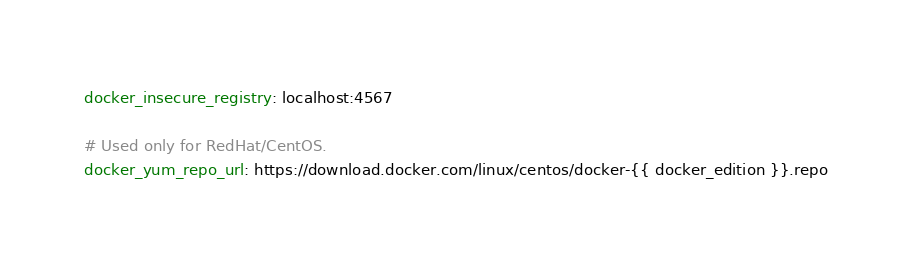Convert code to text. <code><loc_0><loc_0><loc_500><loc_500><_YAML_>docker_insecure_registry: localhost:4567

# Used only for RedHat/CentOS.
docker_yum_repo_url: https://download.docker.com/linux/centos/docker-{{ docker_edition }}.repo
</code> 